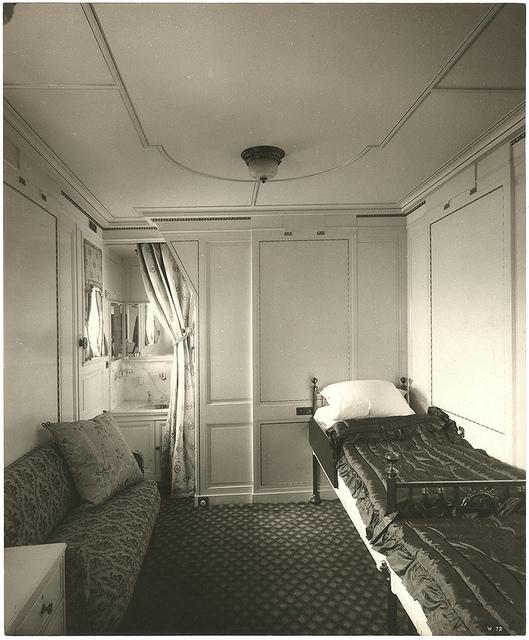Where is the sink?
Answer briefly. Behind curtain. Is this room spacious?
Concise answer only. No. How many pillows are on the couch?
Answer briefly. 1. What are the color of the sheets?
Be succinct. White. 